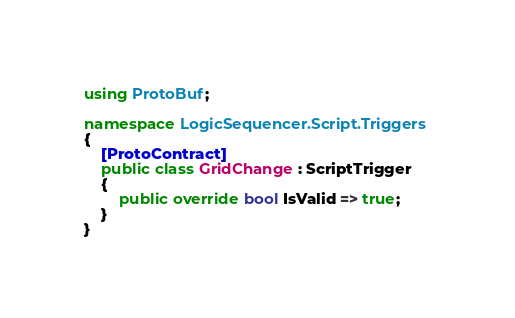Convert code to text. <code><loc_0><loc_0><loc_500><loc_500><_C#_>using ProtoBuf;

namespace LogicSequencer.Script.Triggers
{
    [ProtoContract]
    public class GridChange : ScriptTrigger
    {
        public override bool IsValid => true;
    }
}
</code> 